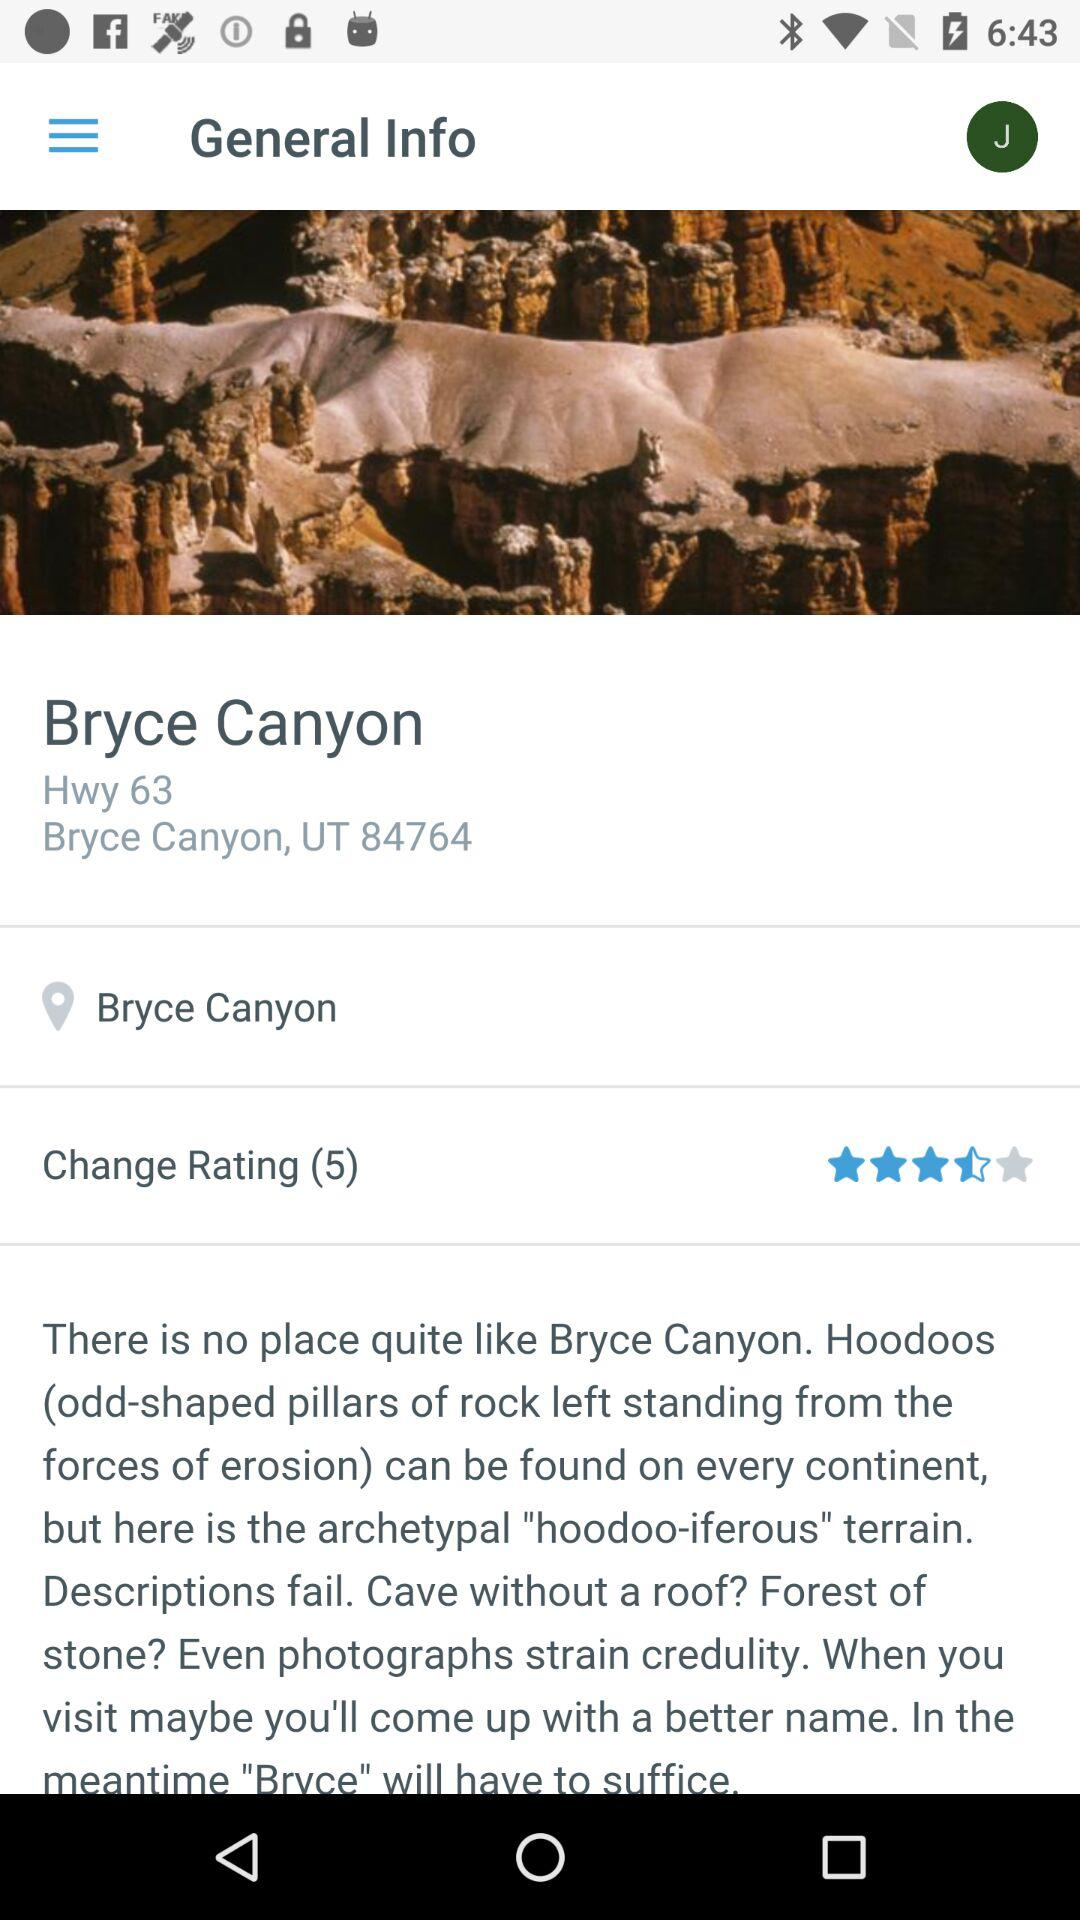What is the rating? The rating is 3.5 stars. 